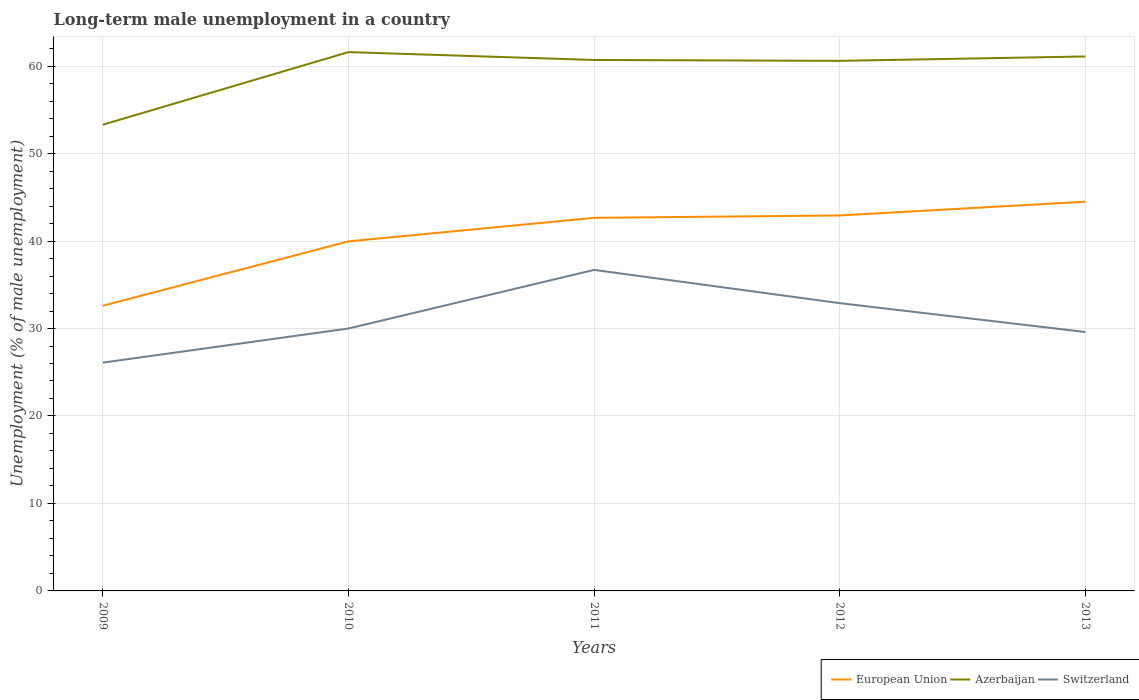Is the number of lines equal to the number of legend labels?
Ensure brevity in your answer.  Yes. Across all years, what is the maximum percentage of long-term unemployed male population in European Union?
Your response must be concise. 32.6. What is the total percentage of long-term unemployed male population in Switzerland in the graph?
Ensure brevity in your answer.  -6.8. What is the difference between the highest and the second highest percentage of long-term unemployed male population in Azerbaijan?
Offer a terse response. 8.3. What is the difference between the highest and the lowest percentage of long-term unemployed male population in European Union?
Your response must be concise. 3. Is the percentage of long-term unemployed male population in Azerbaijan strictly greater than the percentage of long-term unemployed male population in Switzerland over the years?
Your answer should be compact. No. How many lines are there?
Your response must be concise. 3. What is the difference between two consecutive major ticks on the Y-axis?
Ensure brevity in your answer.  10. Are the values on the major ticks of Y-axis written in scientific E-notation?
Your response must be concise. No. Does the graph contain any zero values?
Your answer should be very brief. No. Where does the legend appear in the graph?
Keep it short and to the point. Bottom right. How are the legend labels stacked?
Keep it short and to the point. Horizontal. What is the title of the graph?
Your answer should be compact. Long-term male unemployment in a country. What is the label or title of the X-axis?
Provide a succinct answer. Years. What is the label or title of the Y-axis?
Keep it short and to the point. Unemployment (% of male unemployment). What is the Unemployment (% of male unemployment) in European Union in 2009?
Provide a succinct answer. 32.6. What is the Unemployment (% of male unemployment) in Azerbaijan in 2009?
Give a very brief answer. 53.3. What is the Unemployment (% of male unemployment) of Switzerland in 2009?
Your answer should be very brief. 26.1. What is the Unemployment (% of male unemployment) of European Union in 2010?
Make the answer very short. 39.96. What is the Unemployment (% of male unemployment) in Azerbaijan in 2010?
Offer a very short reply. 61.6. What is the Unemployment (% of male unemployment) of European Union in 2011?
Keep it short and to the point. 42.65. What is the Unemployment (% of male unemployment) of Azerbaijan in 2011?
Provide a succinct answer. 60.7. What is the Unemployment (% of male unemployment) in Switzerland in 2011?
Your answer should be compact. 36.7. What is the Unemployment (% of male unemployment) of European Union in 2012?
Make the answer very short. 42.92. What is the Unemployment (% of male unemployment) in Azerbaijan in 2012?
Keep it short and to the point. 60.6. What is the Unemployment (% of male unemployment) of Switzerland in 2012?
Your answer should be compact. 32.9. What is the Unemployment (% of male unemployment) of European Union in 2013?
Provide a succinct answer. 44.5. What is the Unemployment (% of male unemployment) in Azerbaijan in 2013?
Your answer should be very brief. 61.1. What is the Unemployment (% of male unemployment) in Switzerland in 2013?
Your answer should be very brief. 29.6. Across all years, what is the maximum Unemployment (% of male unemployment) in European Union?
Give a very brief answer. 44.5. Across all years, what is the maximum Unemployment (% of male unemployment) in Azerbaijan?
Offer a terse response. 61.6. Across all years, what is the maximum Unemployment (% of male unemployment) in Switzerland?
Ensure brevity in your answer.  36.7. Across all years, what is the minimum Unemployment (% of male unemployment) in European Union?
Provide a succinct answer. 32.6. Across all years, what is the minimum Unemployment (% of male unemployment) in Azerbaijan?
Give a very brief answer. 53.3. Across all years, what is the minimum Unemployment (% of male unemployment) in Switzerland?
Offer a very short reply. 26.1. What is the total Unemployment (% of male unemployment) of European Union in the graph?
Offer a very short reply. 202.64. What is the total Unemployment (% of male unemployment) of Azerbaijan in the graph?
Offer a very short reply. 297.3. What is the total Unemployment (% of male unemployment) of Switzerland in the graph?
Your answer should be very brief. 155.3. What is the difference between the Unemployment (% of male unemployment) in European Union in 2009 and that in 2010?
Your answer should be very brief. -7.36. What is the difference between the Unemployment (% of male unemployment) of European Union in 2009 and that in 2011?
Make the answer very short. -10.05. What is the difference between the Unemployment (% of male unemployment) of Switzerland in 2009 and that in 2011?
Offer a terse response. -10.6. What is the difference between the Unemployment (% of male unemployment) in European Union in 2009 and that in 2012?
Provide a short and direct response. -10.32. What is the difference between the Unemployment (% of male unemployment) in Azerbaijan in 2009 and that in 2012?
Give a very brief answer. -7.3. What is the difference between the Unemployment (% of male unemployment) in European Union in 2009 and that in 2013?
Offer a very short reply. -11.89. What is the difference between the Unemployment (% of male unemployment) in European Union in 2010 and that in 2011?
Offer a very short reply. -2.69. What is the difference between the Unemployment (% of male unemployment) in European Union in 2010 and that in 2012?
Provide a succinct answer. -2.96. What is the difference between the Unemployment (% of male unemployment) of European Union in 2010 and that in 2013?
Your answer should be very brief. -4.54. What is the difference between the Unemployment (% of male unemployment) in Azerbaijan in 2010 and that in 2013?
Keep it short and to the point. 0.5. What is the difference between the Unemployment (% of male unemployment) in European Union in 2011 and that in 2012?
Provide a short and direct response. -0.27. What is the difference between the Unemployment (% of male unemployment) in Azerbaijan in 2011 and that in 2012?
Make the answer very short. 0.1. What is the difference between the Unemployment (% of male unemployment) of European Union in 2011 and that in 2013?
Offer a very short reply. -1.84. What is the difference between the Unemployment (% of male unemployment) of Azerbaijan in 2011 and that in 2013?
Your answer should be compact. -0.4. What is the difference between the Unemployment (% of male unemployment) of European Union in 2012 and that in 2013?
Your response must be concise. -1.57. What is the difference between the Unemployment (% of male unemployment) in European Union in 2009 and the Unemployment (% of male unemployment) in Azerbaijan in 2010?
Offer a very short reply. -29. What is the difference between the Unemployment (% of male unemployment) of European Union in 2009 and the Unemployment (% of male unemployment) of Switzerland in 2010?
Your answer should be very brief. 2.6. What is the difference between the Unemployment (% of male unemployment) in Azerbaijan in 2009 and the Unemployment (% of male unemployment) in Switzerland in 2010?
Your answer should be compact. 23.3. What is the difference between the Unemployment (% of male unemployment) of European Union in 2009 and the Unemployment (% of male unemployment) of Azerbaijan in 2011?
Make the answer very short. -28.1. What is the difference between the Unemployment (% of male unemployment) in European Union in 2009 and the Unemployment (% of male unemployment) in Switzerland in 2011?
Provide a short and direct response. -4.1. What is the difference between the Unemployment (% of male unemployment) in European Union in 2009 and the Unemployment (% of male unemployment) in Azerbaijan in 2012?
Your response must be concise. -28. What is the difference between the Unemployment (% of male unemployment) of European Union in 2009 and the Unemployment (% of male unemployment) of Switzerland in 2012?
Provide a succinct answer. -0.3. What is the difference between the Unemployment (% of male unemployment) of Azerbaijan in 2009 and the Unemployment (% of male unemployment) of Switzerland in 2012?
Provide a short and direct response. 20.4. What is the difference between the Unemployment (% of male unemployment) in European Union in 2009 and the Unemployment (% of male unemployment) in Azerbaijan in 2013?
Offer a terse response. -28.5. What is the difference between the Unemployment (% of male unemployment) of European Union in 2009 and the Unemployment (% of male unemployment) of Switzerland in 2013?
Offer a terse response. 3. What is the difference between the Unemployment (% of male unemployment) of Azerbaijan in 2009 and the Unemployment (% of male unemployment) of Switzerland in 2013?
Keep it short and to the point. 23.7. What is the difference between the Unemployment (% of male unemployment) in European Union in 2010 and the Unemployment (% of male unemployment) in Azerbaijan in 2011?
Provide a short and direct response. -20.74. What is the difference between the Unemployment (% of male unemployment) in European Union in 2010 and the Unemployment (% of male unemployment) in Switzerland in 2011?
Keep it short and to the point. 3.26. What is the difference between the Unemployment (% of male unemployment) of Azerbaijan in 2010 and the Unemployment (% of male unemployment) of Switzerland in 2011?
Offer a terse response. 24.9. What is the difference between the Unemployment (% of male unemployment) of European Union in 2010 and the Unemployment (% of male unemployment) of Azerbaijan in 2012?
Provide a short and direct response. -20.64. What is the difference between the Unemployment (% of male unemployment) in European Union in 2010 and the Unemployment (% of male unemployment) in Switzerland in 2012?
Make the answer very short. 7.06. What is the difference between the Unemployment (% of male unemployment) of Azerbaijan in 2010 and the Unemployment (% of male unemployment) of Switzerland in 2012?
Offer a very short reply. 28.7. What is the difference between the Unemployment (% of male unemployment) of European Union in 2010 and the Unemployment (% of male unemployment) of Azerbaijan in 2013?
Offer a very short reply. -21.14. What is the difference between the Unemployment (% of male unemployment) in European Union in 2010 and the Unemployment (% of male unemployment) in Switzerland in 2013?
Give a very brief answer. 10.36. What is the difference between the Unemployment (% of male unemployment) of European Union in 2011 and the Unemployment (% of male unemployment) of Azerbaijan in 2012?
Provide a short and direct response. -17.95. What is the difference between the Unemployment (% of male unemployment) of European Union in 2011 and the Unemployment (% of male unemployment) of Switzerland in 2012?
Give a very brief answer. 9.75. What is the difference between the Unemployment (% of male unemployment) of Azerbaijan in 2011 and the Unemployment (% of male unemployment) of Switzerland in 2012?
Ensure brevity in your answer.  27.8. What is the difference between the Unemployment (% of male unemployment) in European Union in 2011 and the Unemployment (% of male unemployment) in Azerbaijan in 2013?
Give a very brief answer. -18.45. What is the difference between the Unemployment (% of male unemployment) of European Union in 2011 and the Unemployment (% of male unemployment) of Switzerland in 2013?
Offer a terse response. 13.05. What is the difference between the Unemployment (% of male unemployment) of Azerbaijan in 2011 and the Unemployment (% of male unemployment) of Switzerland in 2013?
Provide a short and direct response. 31.1. What is the difference between the Unemployment (% of male unemployment) of European Union in 2012 and the Unemployment (% of male unemployment) of Azerbaijan in 2013?
Offer a terse response. -18.18. What is the difference between the Unemployment (% of male unemployment) in European Union in 2012 and the Unemployment (% of male unemployment) in Switzerland in 2013?
Provide a succinct answer. 13.32. What is the difference between the Unemployment (% of male unemployment) in Azerbaijan in 2012 and the Unemployment (% of male unemployment) in Switzerland in 2013?
Offer a terse response. 31. What is the average Unemployment (% of male unemployment) in European Union per year?
Offer a terse response. 40.53. What is the average Unemployment (% of male unemployment) in Azerbaijan per year?
Give a very brief answer. 59.46. What is the average Unemployment (% of male unemployment) in Switzerland per year?
Give a very brief answer. 31.06. In the year 2009, what is the difference between the Unemployment (% of male unemployment) of European Union and Unemployment (% of male unemployment) of Azerbaijan?
Provide a succinct answer. -20.7. In the year 2009, what is the difference between the Unemployment (% of male unemployment) of European Union and Unemployment (% of male unemployment) of Switzerland?
Keep it short and to the point. 6.5. In the year 2009, what is the difference between the Unemployment (% of male unemployment) in Azerbaijan and Unemployment (% of male unemployment) in Switzerland?
Keep it short and to the point. 27.2. In the year 2010, what is the difference between the Unemployment (% of male unemployment) of European Union and Unemployment (% of male unemployment) of Azerbaijan?
Provide a short and direct response. -21.64. In the year 2010, what is the difference between the Unemployment (% of male unemployment) in European Union and Unemployment (% of male unemployment) in Switzerland?
Your response must be concise. 9.96. In the year 2010, what is the difference between the Unemployment (% of male unemployment) in Azerbaijan and Unemployment (% of male unemployment) in Switzerland?
Make the answer very short. 31.6. In the year 2011, what is the difference between the Unemployment (% of male unemployment) in European Union and Unemployment (% of male unemployment) in Azerbaijan?
Your answer should be compact. -18.05. In the year 2011, what is the difference between the Unemployment (% of male unemployment) of European Union and Unemployment (% of male unemployment) of Switzerland?
Provide a short and direct response. 5.95. In the year 2011, what is the difference between the Unemployment (% of male unemployment) in Azerbaijan and Unemployment (% of male unemployment) in Switzerland?
Your answer should be very brief. 24. In the year 2012, what is the difference between the Unemployment (% of male unemployment) of European Union and Unemployment (% of male unemployment) of Azerbaijan?
Give a very brief answer. -17.68. In the year 2012, what is the difference between the Unemployment (% of male unemployment) in European Union and Unemployment (% of male unemployment) in Switzerland?
Provide a short and direct response. 10.02. In the year 2012, what is the difference between the Unemployment (% of male unemployment) in Azerbaijan and Unemployment (% of male unemployment) in Switzerland?
Your response must be concise. 27.7. In the year 2013, what is the difference between the Unemployment (% of male unemployment) of European Union and Unemployment (% of male unemployment) of Azerbaijan?
Make the answer very short. -16.6. In the year 2013, what is the difference between the Unemployment (% of male unemployment) of European Union and Unemployment (% of male unemployment) of Switzerland?
Give a very brief answer. 14.9. In the year 2013, what is the difference between the Unemployment (% of male unemployment) in Azerbaijan and Unemployment (% of male unemployment) in Switzerland?
Keep it short and to the point. 31.5. What is the ratio of the Unemployment (% of male unemployment) of European Union in 2009 to that in 2010?
Make the answer very short. 0.82. What is the ratio of the Unemployment (% of male unemployment) in Azerbaijan in 2009 to that in 2010?
Your answer should be very brief. 0.87. What is the ratio of the Unemployment (% of male unemployment) in Switzerland in 2009 to that in 2010?
Offer a terse response. 0.87. What is the ratio of the Unemployment (% of male unemployment) in European Union in 2009 to that in 2011?
Your answer should be compact. 0.76. What is the ratio of the Unemployment (% of male unemployment) of Azerbaijan in 2009 to that in 2011?
Provide a succinct answer. 0.88. What is the ratio of the Unemployment (% of male unemployment) of Switzerland in 2009 to that in 2011?
Offer a terse response. 0.71. What is the ratio of the Unemployment (% of male unemployment) in European Union in 2009 to that in 2012?
Offer a terse response. 0.76. What is the ratio of the Unemployment (% of male unemployment) in Azerbaijan in 2009 to that in 2012?
Your answer should be very brief. 0.88. What is the ratio of the Unemployment (% of male unemployment) of Switzerland in 2009 to that in 2012?
Ensure brevity in your answer.  0.79. What is the ratio of the Unemployment (% of male unemployment) in European Union in 2009 to that in 2013?
Make the answer very short. 0.73. What is the ratio of the Unemployment (% of male unemployment) of Azerbaijan in 2009 to that in 2013?
Provide a succinct answer. 0.87. What is the ratio of the Unemployment (% of male unemployment) of Switzerland in 2009 to that in 2013?
Your answer should be compact. 0.88. What is the ratio of the Unemployment (% of male unemployment) in European Union in 2010 to that in 2011?
Ensure brevity in your answer.  0.94. What is the ratio of the Unemployment (% of male unemployment) of Azerbaijan in 2010 to that in 2011?
Keep it short and to the point. 1.01. What is the ratio of the Unemployment (% of male unemployment) of Switzerland in 2010 to that in 2011?
Provide a succinct answer. 0.82. What is the ratio of the Unemployment (% of male unemployment) of European Union in 2010 to that in 2012?
Give a very brief answer. 0.93. What is the ratio of the Unemployment (% of male unemployment) in Azerbaijan in 2010 to that in 2012?
Offer a terse response. 1.02. What is the ratio of the Unemployment (% of male unemployment) of Switzerland in 2010 to that in 2012?
Give a very brief answer. 0.91. What is the ratio of the Unemployment (% of male unemployment) of European Union in 2010 to that in 2013?
Keep it short and to the point. 0.9. What is the ratio of the Unemployment (% of male unemployment) in Azerbaijan in 2010 to that in 2013?
Your answer should be very brief. 1.01. What is the ratio of the Unemployment (% of male unemployment) of Switzerland in 2010 to that in 2013?
Make the answer very short. 1.01. What is the ratio of the Unemployment (% of male unemployment) in European Union in 2011 to that in 2012?
Your response must be concise. 0.99. What is the ratio of the Unemployment (% of male unemployment) in Switzerland in 2011 to that in 2012?
Provide a short and direct response. 1.12. What is the ratio of the Unemployment (% of male unemployment) of European Union in 2011 to that in 2013?
Your answer should be very brief. 0.96. What is the ratio of the Unemployment (% of male unemployment) of Switzerland in 2011 to that in 2013?
Provide a succinct answer. 1.24. What is the ratio of the Unemployment (% of male unemployment) in European Union in 2012 to that in 2013?
Ensure brevity in your answer.  0.96. What is the ratio of the Unemployment (% of male unemployment) of Switzerland in 2012 to that in 2013?
Provide a short and direct response. 1.11. What is the difference between the highest and the second highest Unemployment (% of male unemployment) of European Union?
Your answer should be very brief. 1.57. What is the difference between the highest and the second highest Unemployment (% of male unemployment) in Azerbaijan?
Your answer should be compact. 0.5. What is the difference between the highest and the lowest Unemployment (% of male unemployment) of European Union?
Your answer should be compact. 11.89. What is the difference between the highest and the lowest Unemployment (% of male unemployment) of Azerbaijan?
Provide a succinct answer. 8.3. 